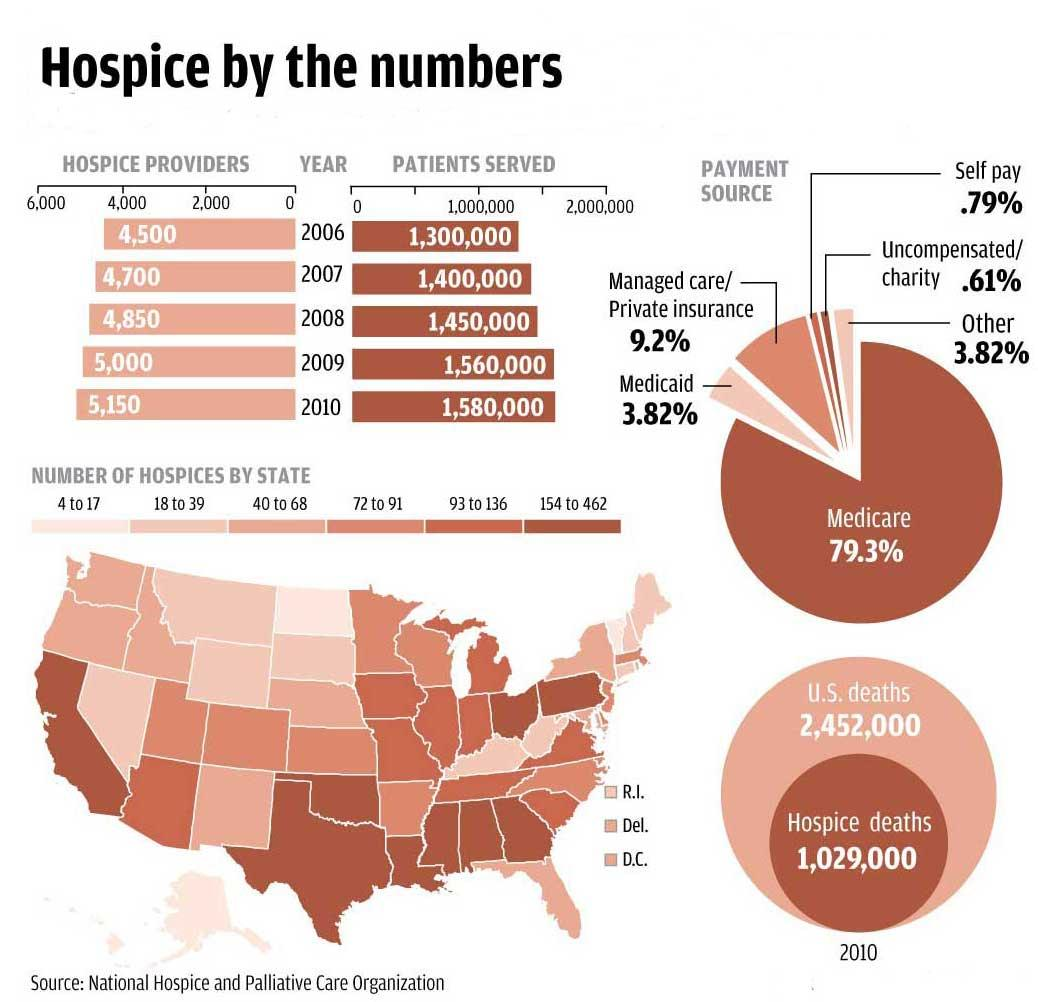Mention a couple of crucial points in this snapshot. In 2010, the highest number of patients was served compared to 2006 and 2008. During the year following 2007, a total of 1,450,000 patients were served. The pie chart shows that two payment sources, "Other" and "Medicaid," contribute 3.82% to the total payment amounts. The aggregate of payment sources contributed by Medicaid and Managed Care was 13.02%. In 2010, the number of patients served by the healthcare organization was 2,80,000, which was higher than the number of patients served in 2006. 